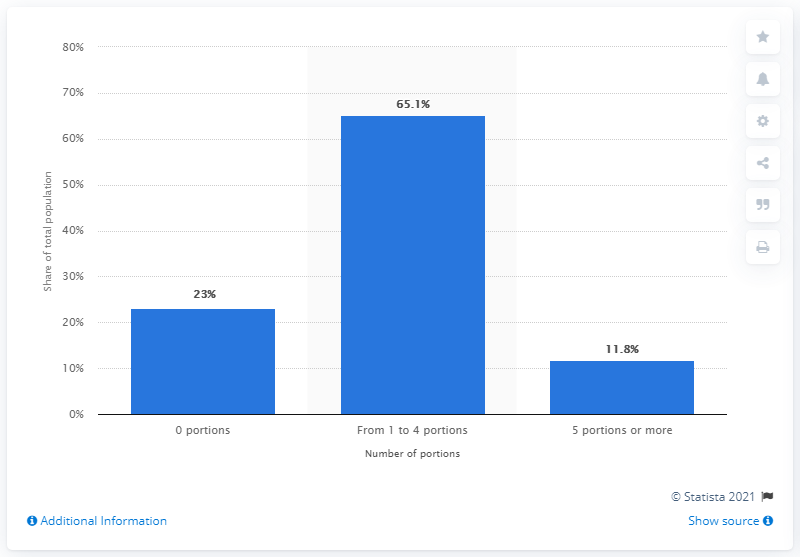List a handful of essential elements in this visual. In 2014, 65.1% of the Italian population consumed one to four portions of fruits and vegetables per day. 